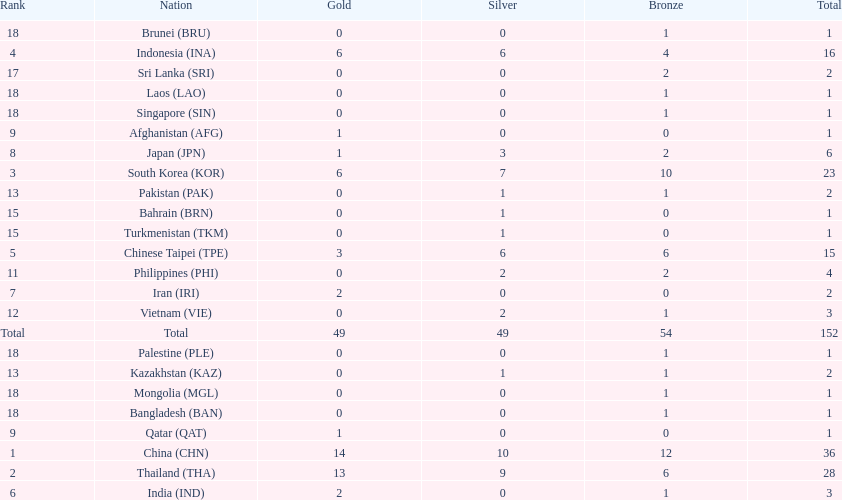How many nations won no silver medals at all? 11. 